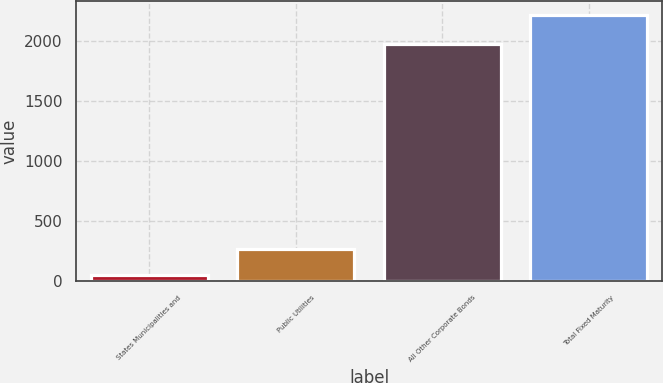Convert chart to OTSL. <chart><loc_0><loc_0><loc_500><loc_500><bar_chart><fcel>States Municipalities and<fcel>Public Utilities<fcel>All Other Corporate Bonds<fcel>Total Fixed Maturity<nl><fcel>53<fcel>269.54<fcel>1977.1<fcel>2218.4<nl></chart> 